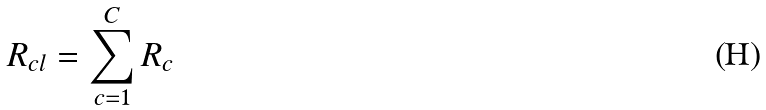<formula> <loc_0><loc_0><loc_500><loc_500>R _ { c l } = \sum _ { c = 1 } ^ { C } R _ { c }</formula> 